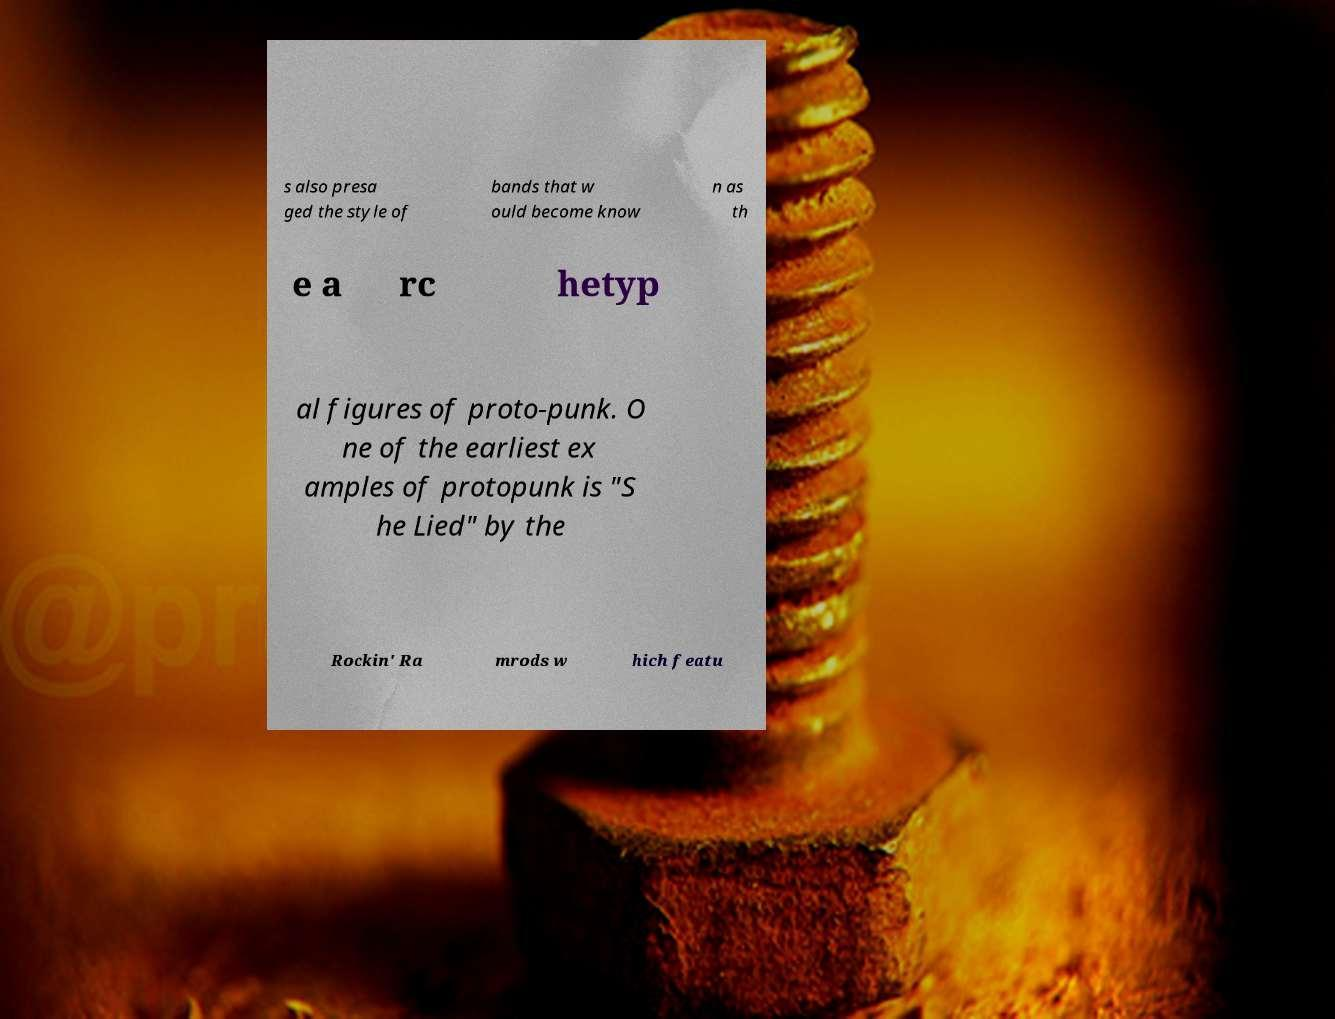Can you read and provide the text displayed in the image?This photo seems to have some interesting text. Can you extract and type it out for me? s also presa ged the style of bands that w ould become know n as th e a rc hetyp al figures of proto-punk. O ne of the earliest ex amples of protopunk is "S he Lied" by the Rockin' Ra mrods w hich featu 